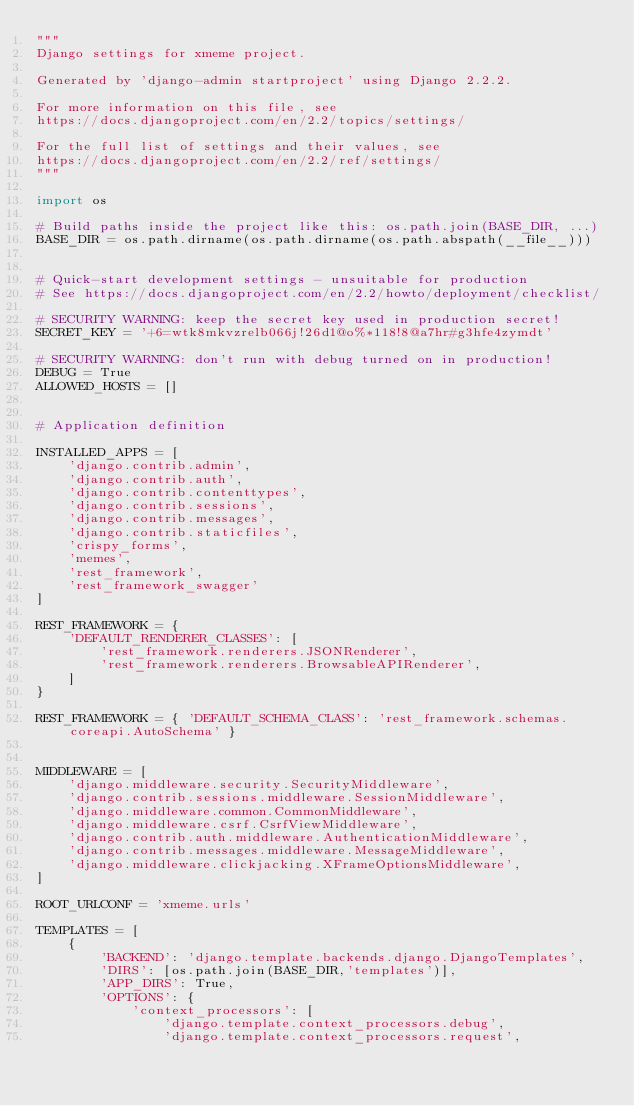<code> <loc_0><loc_0><loc_500><loc_500><_Python_>"""
Django settings for xmeme project.

Generated by 'django-admin startproject' using Django 2.2.2.

For more information on this file, see
https://docs.djangoproject.com/en/2.2/topics/settings/

For the full list of settings and their values, see
https://docs.djangoproject.com/en/2.2/ref/settings/
"""

import os

# Build paths inside the project like this: os.path.join(BASE_DIR, ...)
BASE_DIR = os.path.dirname(os.path.dirname(os.path.abspath(__file__)))


# Quick-start development settings - unsuitable for production
# See https://docs.djangoproject.com/en/2.2/howto/deployment/checklist/

# SECURITY WARNING: keep the secret key used in production secret!
SECRET_KEY = '+6=wtk8mkvzrelb066j!26d1@o%*118!8@a7hr#g3hfe4zymdt'

# SECURITY WARNING: don't run with debug turned on in production!
DEBUG = True
ALLOWED_HOSTS = []


# Application definition

INSTALLED_APPS = [
    'django.contrib.admin',
    'django.contrib.auth',
    'django.contrib.contenttypes',
    'django.contrib.sessions',
    'django.contrib.messages',
    'django.contrib.staticfiles',
    'crispy_forms',
    'memes',
    'rest_framework',  
    'rest_framework_swagger'
]

REST_FRAMEWORK = {
    'DEFAULT_RENDERER_CLASSES': [
        'rest_framework.renderers.JSONRenderer',
        'rest_framework.renderers.BrowsableAPIRenderer',
    ]
}

REST_FRAMEWORK = { 'DEFAULT_SCHEMA_CLASS': 'rest_framework.schemas.coreapi.AutoSchema' }


MIDDLEWARE = [
    'django.middleware.security.SecurityMiddleware',
    'django.contrib.sessions.middleware.SessionMiddleware',
    'django.middleware.common.CommonMiddleware',
    'django.middleware.csrf.CsrfViewMiddleware',
    'django.contrib.auth.middleware.AuthenticationMiddleware',
    'django.contrib.messages.middleware.MessageMiddleware',
    'django.middleware.clickjacking.XFrameOptionsMiddleware',   
]

ROOT_URLCONF = 'xmeme.urls'

TEMPLATES = [
    {
        'BACKEND': 'django.template.backends.django.DjangoTemplates',
        'DIRS': [os.path.join(BASE_DIR,'templates')],
        'APP_DIRS': True,
        'OPTIONS': {
            'context_processors': [
                'django.template.context_processors.debug',
                'django.template.context_processors.request',</code> 